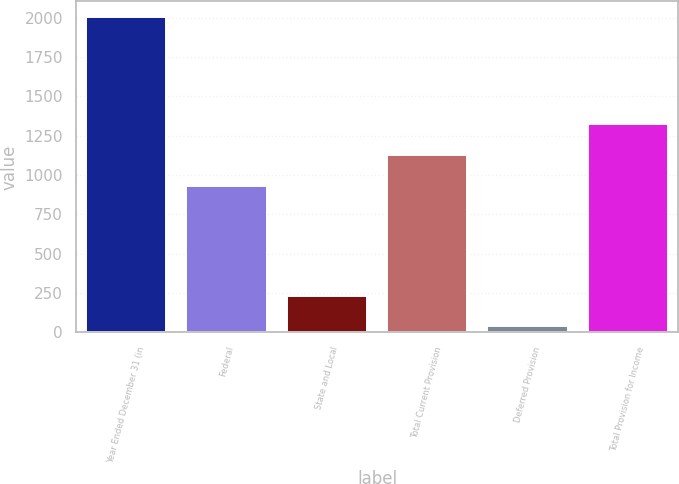<chart> <loc_0><loc_0><loc_500><loc_500><bar_chart><fcel>Year Ended December 31 (in<fcel>Federal<fcel>State and Local<fcel>Total Current Provision<fcel>Deferred Provision<fcel>Total Provision for Income<nl><fcel>2003<fcel>932<fcel>233.6<fcel>1128.6<fcel>37<fcel>1325.2<nl></chart> 